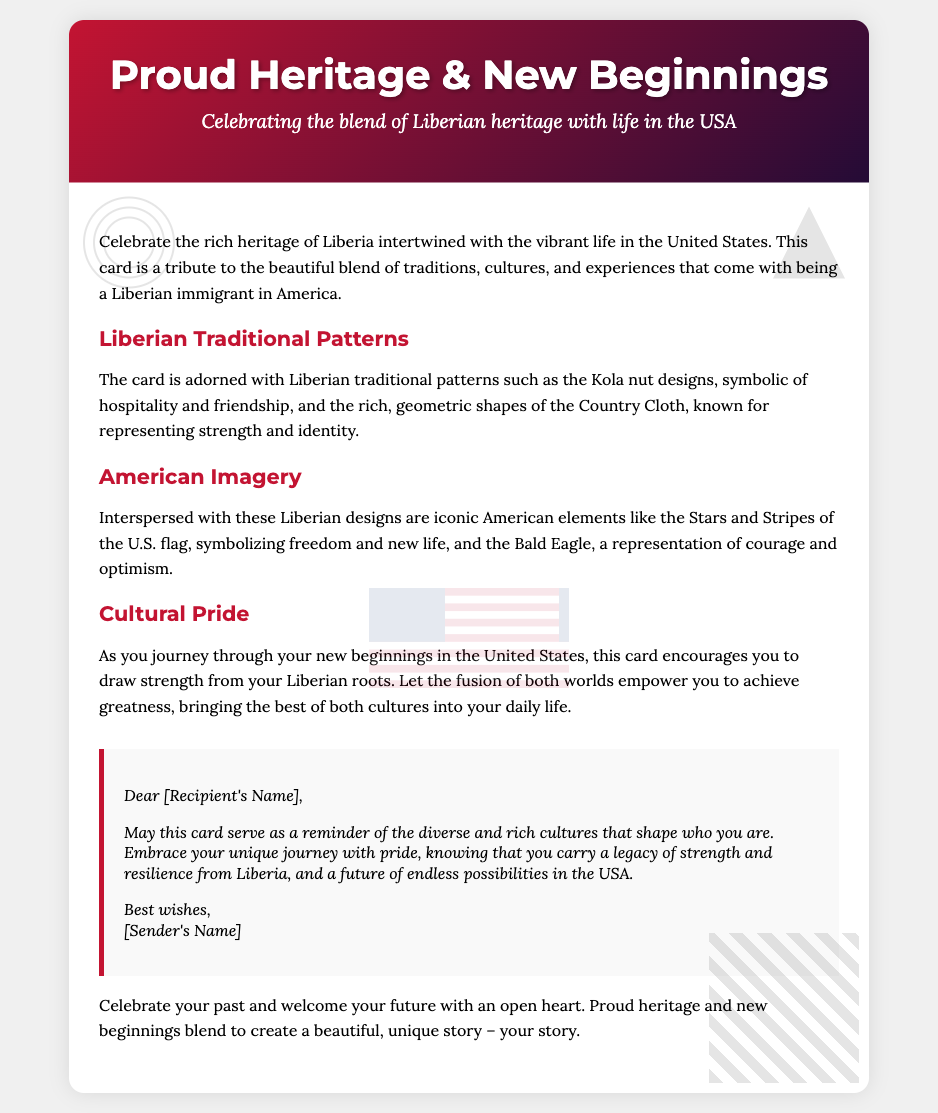What is the title of the card? The title of the card is found in the card header section, which prominently displays the title.
Answer: Proud Heritage & New Beginnings What are the two main cultures celebrated in this card? The card specifically mentions the cultures being honored in the document body.
Answer: Liberian and American What traditional Liberian design is mentioned in the card? The document discusses various designs, one of which is specifically highlighted as a traditional pattern.
Answer: Kola nut designs What American symbol is included as part of the card's decoration? The document lists specific American imagery and symbols that are included in the design of the card.
Answer: U.S. flag What is the color of the card's header background? The background color of the card's header is described in the document's style.
Answer: Gradient (from red to dark purple) What does the personal message encourage the recipient to embrace? The personal message highlights a specific sentiment aimed at the recipient, reflecting the overall theme of the card.
Answer: Unique journey with pride What is the symbolism of the Kola nut in the card? The document describes the meanings associated with the Liberian traditional patterns included in the card.
Answer: Hospitality and friendship How many sections are there in the card body? The count of sections is found by identifying the individual segments described in the document body.
Answer: Four sections What does the card suggest about cultural pride? The examination of the document reveals the card's perspective and advice regarding cultural identity.
Answer: Draw strength from roots 